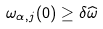<formula> <loc_0><loc_0><loc_500><loc_500>\omega _ { \alpha , j } ( 0 ) \geq \delta \widehat { \omega }</formula> 